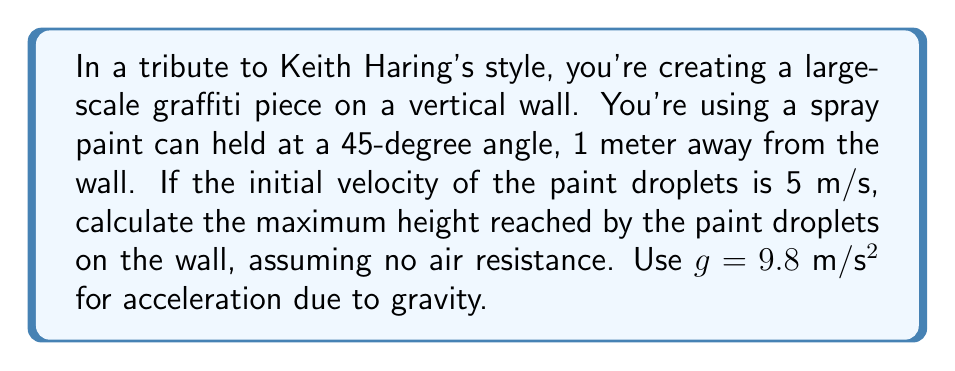Provide a solution to this math problem. Let's approach this step-by-step:

1) First, we need to decompose the initial velocity into its horizontal and vertical components. Since the spray can is held at a 45-degree angle:

   $v_x = v_y = 5 \cdot \cos(45°) = 5 \cdot \frac{\sqrt{2}}{2} \approx 3.54$ m/s

2) The time it takes for the droplet to reach the wall is determined by the horizontal distance and velocity:

   $t = \frac{distance}{v_x} = \frac{1}{3.54} \approx 0.282$ seconds

3) Now, we can use the equation for the vertical displacement of a projectile:

   $y = v_y t - \frac{1}{2}gt^2$

4) Substituting our values:

   $y = 3.54 \cdot 0.282 - \frac{1}{2} \cdot 9.8 \cdot 0.282^2$

5) Calculating:

   $y = 0.998 - 0.390 = 0.608$ meters

Therefore, the maximum height reached by the paint droplets on the wall is approximately 0.608 meters or about 60.8 cm above the point of aim.
Answer: 0.608 m 